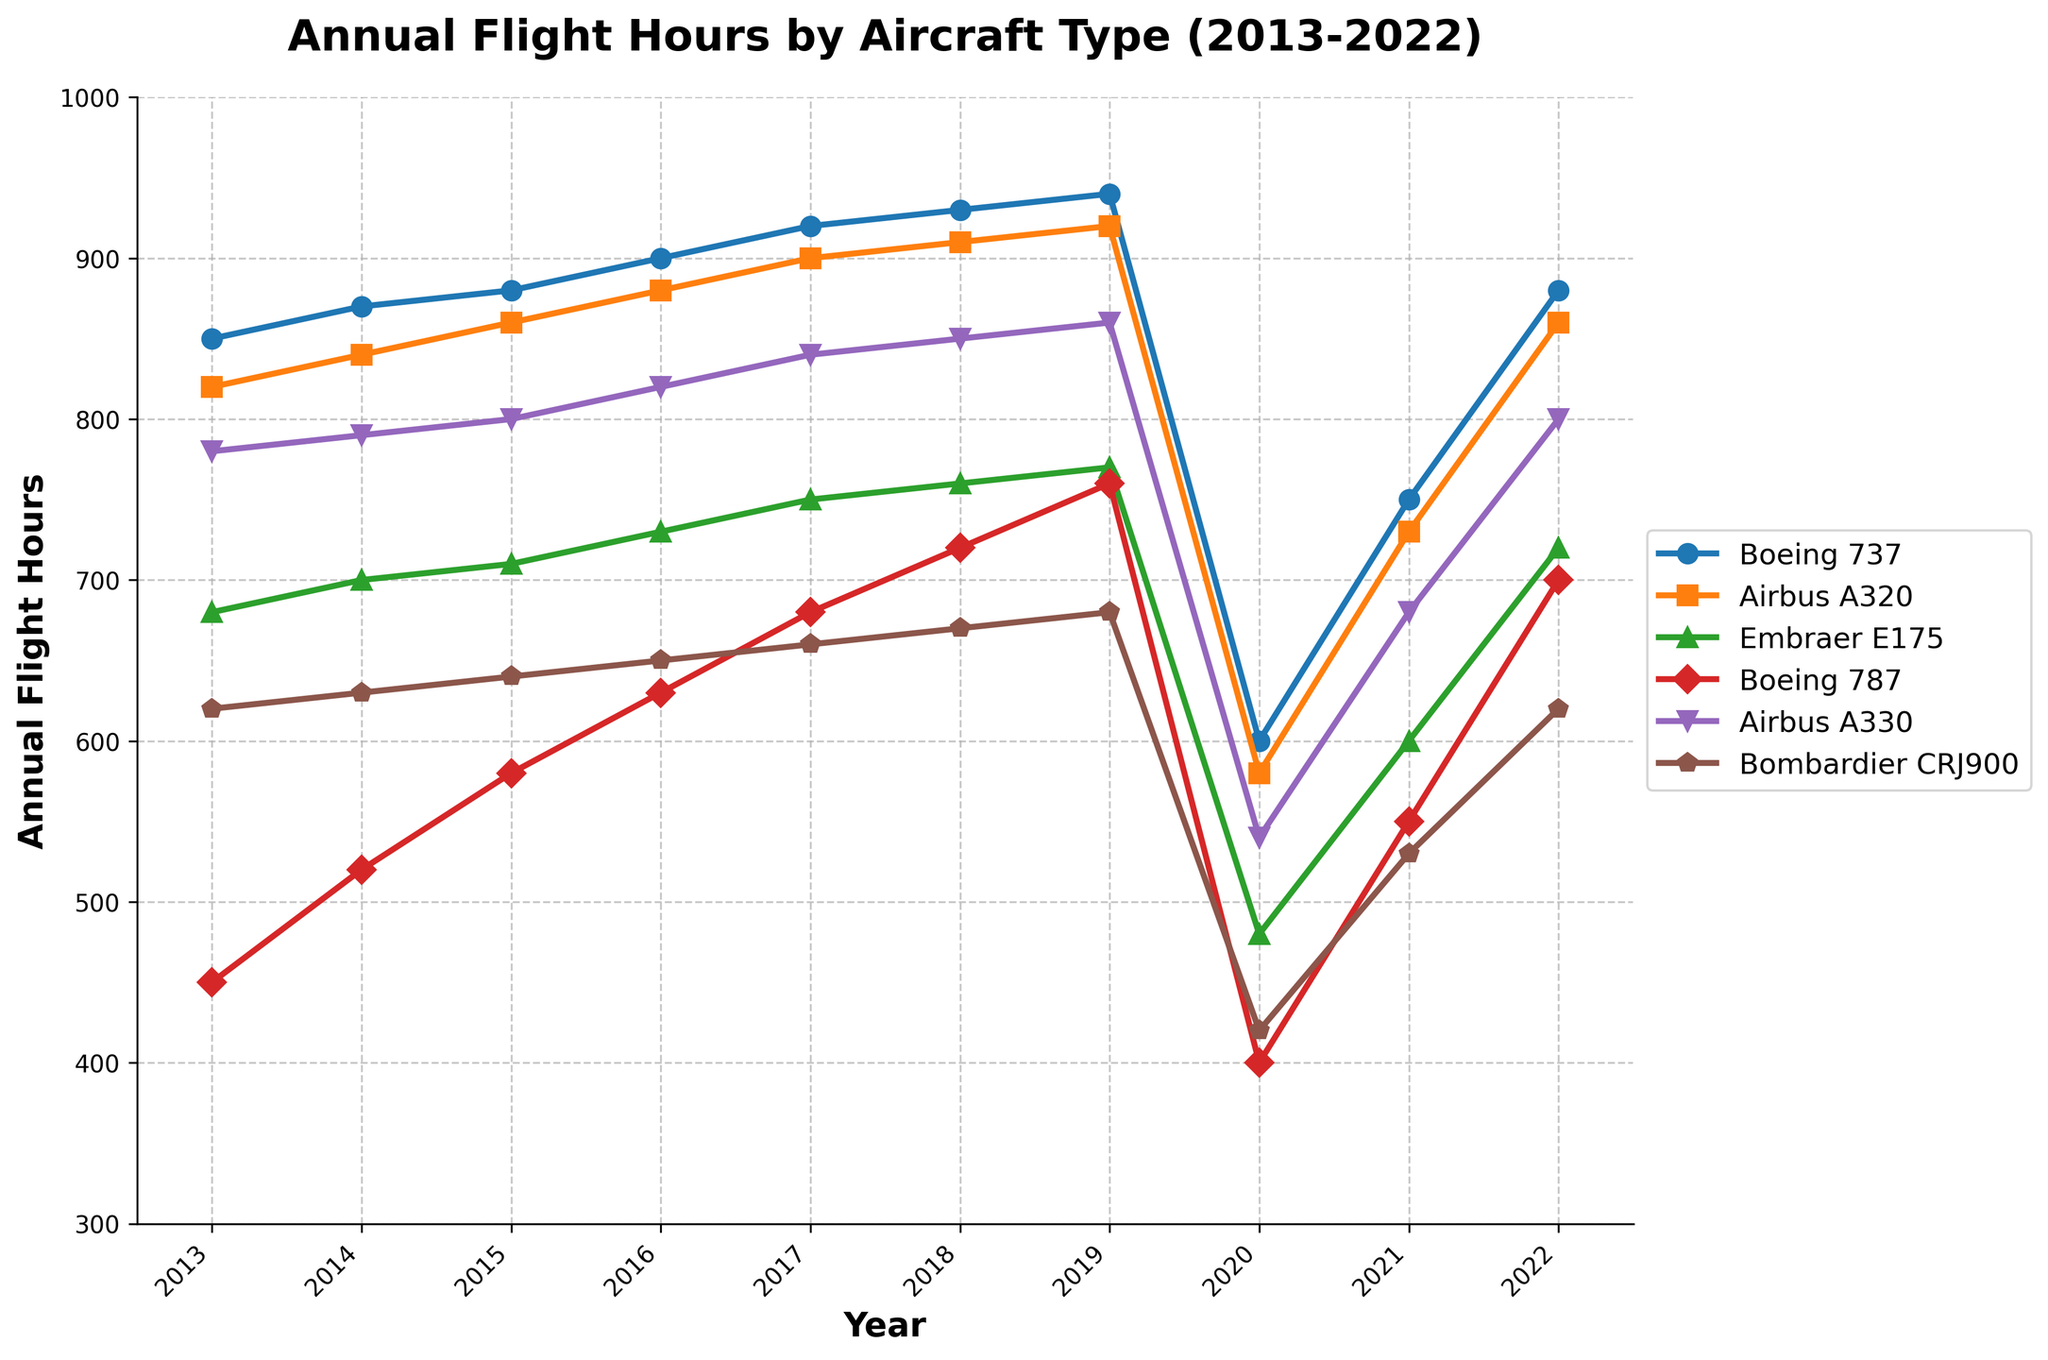What's the annual flight hours for the Airbus A320 in 2016? To find the annual flight hours for the Airbus A320 in 2016, look for the corresponding year on the x-axis and then identify the value on the y-axis associated with the Airbus A320's line.
Answer: 880 Which aircraft type had the fewest flight hours in 2017? To determine which aircraft type had the fewest flight hours in 2017, compare the values on the y-axis for each aircraft type's line at the year 2017.
Answer: Boeing 787 How did the annual flight hours for the Boeing 737 change between 2019 and 2020? To determine the change, locate the flight hours for the Boeing 737 in both 2019 and 2020 on the y-axis and then find the difference (subtract 2020 value from the 2019 value).
Answer: Decreased by 340 Which aircraft type showed the most significant drop in flight hours in 2020? Compare the flight hours for each aircraft type between 2019 and 2020, and identify which aircraft type had the largest negative difference.
Answer: Airbus A330 What was the total annual flight hours for all aircraft types in 2021? Sum the flight hours of all aircraft types for the year 2021. The values are Airbus A320 (730), Boeing 737 (750), Embraer E175 (600), Boeing 787 (550), Airbus A330 (680), and Bombardier CRJ900 (530).
Answer: 3840 Which aircraft type had the most consistent increase in flight hours over the decade (2013-2022)? By observing the plotted lines' trends, identify which aircraft type’s line shows a consistent upward trajectory without significant drops year over year.
Answer: Airbus A320 How many aircraft types exceeded 700 annual flight hours in 2015? Identify the number of aircraft types whose y-axis value is above 700 for the year 2015.
Answer: 4 (Boeing 737, Airbus A320, Airbus A330, Embraer E175) Which two aircraft types had the closest annual flight hours in 2019? Compare the flight hour values for all aircraft types in 2019 to find the two with the smallest difference.
Answer: Boeing 737 and Airbus A320 What was the average annual flight hours for the Bombardier CRJ900 over the given period (2013-2022)? Sum the annual flight hours for the Bombardier CRJ900 for each year and divide by the total number of years (10). The values are 620, 630, 640, 650, 660, 670, 680, 420, 530, and 620.
Answer: 612 Which year marked the lowest annual flight hours for the Boeing 787? By examining the plotted line for the Boeing 787, identify the year where the value on the y-axis is the lowest.
Answer: 2020 